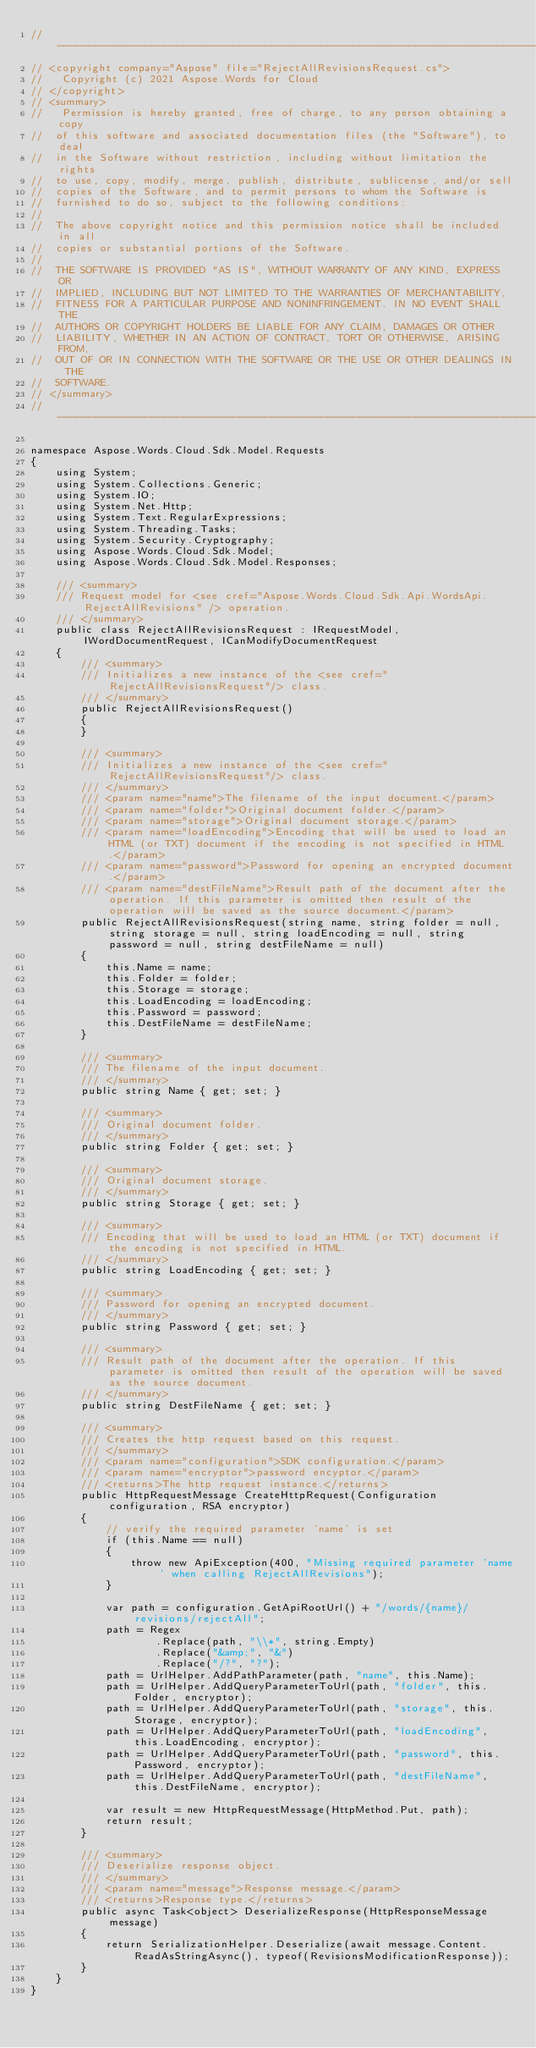Convert code to text. <code><loc_0><loc_0><loc_500><loc_500><_C#_>// --------------------------------------------------------------------------------------------------------------------
// <copyright company="Aspose" file="RejectAllRevisionsRequest.cs">
//   Copyright (c) 2021 Aspose.Words for Cloud
// </copyright>
// <summary>
//   Permission is hereby granted, free of charge, to any person obtaining a copy
//  of this software and associated documentation files (the "Software"), to deal
//  in the Software without restriction, including without limitation the rights
//  to use, copy, modify, merge, publish, distribute, sublicense, and/or sell
//  copies of the Software, and to permit persons to whom the Software is
//  furnished to do so, subject to the following conditions:
// 
//  The above copyright notice and this permission notice shall be included in all
//  copies or substantial portions of the Software.
// 
//  THE SOFTWARE IS PROVIDED "AS IS", WITHOUT WARRANTY OF ANY KIND, EXPRESS OR
//  IMPLIED, INCLUDING BUT NOT LIMITED TO THE WARRANTIES OF MERCHANTABILITY,
//  FITNESS FOR A PARTICULAR PURPOSE AND NONINFRINGEMENT. IN NO EVENT SHALL THE
//  AUTHORS OR COPYRIGHT HOLDERS BE LIABLE FOR ANY CLAIM, DAMAGES OR OTHER
//  LIABILITY, WHETHER IN AN ACTION OF CONTRACT, TORT OR OTHERWISE, ARISING FROM,
//  OUT OF OR IN CONNECTION WITH THE SOFTWARE OR THE USE OR OTHER DEALINGS IN THE
//  SOFTWARE.
// </summary>
// --------------------------------------------------------------------------------------------------------------------

namespace Aspose.Words.Cloud.Sdk.Model.Requests
{
    using System;
    using System.Collections.Generic;
    using System.IO;
    using System.Net.Http;
    using System.Text.RegularExpressions;
    using System.Threading.Tasks;
    using System.Security.Cryptography;
    using Aspose.Words.Cloud.Sdk.Model;
    using Aspose.Words.Cloud.Sdk.Model.Responses;

    /// <summary>
    /// Request model for <see cref="Aspose.Words.Cloud.Sdk.Api.WordsApi.RejectAllRevisions" /> operation.
    /// </summary>
    public class RejectAllRevisionsRequest : IRequestModel, IWordDocumentRequest, ICanModifyDocumentRequest
    {
        /// <summary>
        /// Initializes a new instance of the <see cref="RejectAllRevisionsRequest"/> class.
        /// </summary>
        public RejectAllRevisionsRequest()
        {
        }

        /// <summary>
        /// Initializes a new instance of the <see cref="RejectAllRevisionsRequest"/> class.
        /// </summary>
        /// <param name="name">The filename of the input document.</param>
        /// <param name="folder">Original document folder.</param>
        /// <param name="storage">Original document storage.</param>
        /// <param name="loadEncoding">Encoding that will be used to load an HTML (or TXT) document if the encoding is not specified in HTML.</param>
        /// <param name="password">Password for opening an encrypted document.</param>
        /// <param name="destFileName">Result path of the document after the operation. If this parameter is omitted then result of the operation will be saved as the source document.</param>
        public RejectAllRevisionsRequest(string name, string folder = null, string storage = null, string loadEncoding = null, string password = null, string destFileName = null)
        {
            this.Name = name;
            this.Folder = folder;
            this.Storage = storage;
            this.LoadEncoding = loadEncoding;
            this.Password = password;
            this.DestFileName = destFileName;
        }

        /// <summary>
        /// The filename of the input document.
        /// </summary>
        public string Name { get; set; }

        /// <summary>
        /// Original document folder.
        /// </summary>
        public string Folder { get; set; }

        /// <summary>
        /// Original document storage.
        /// </summary>
        public string Storage { get; set; }

        /// <summary>
        /// Encoding that will be used to load an HTML (or TXT) document if the encoding is not specified in HTML.
        /// </summary>
        public string LoadEncoding { get; set; }

        /// <summary>
        /// Password for opening an encrypted document.
        /// </summary>
        public string Password { get; set; }

        /// <summary>
        /// Result path of the document after the operation. If this parameter is omitted then result of the operation will be saved as the source document.
        /// </summary>
        public string DestFileName { get; set; }

        /// <summary>
        /// Creates the http request based on this request.
        /// </summary>
        /// <param name="configuration">SDK configuration.</param>
        /// <param name="encryptor">password encyptor.</param>
        /// <returns>The http request instance.</returns>
        public HttpRequestMessage CreateHttpRequest(Configuration configuration, RSA encryptor)
        {
            // verify the required parameter 'name' is set
            if (this.Name == null)
            {
                throw new ApiException(400, "Missing required parameter 'name' when calling RejectAllRevisions");
            }

            var path = configuration.GetApiRootUrl() + "/words/{name}/revisions/rejectAll";
            path = Regex
                    .Replace(path, "\\*", string.Empty)
                    .Replace("&amp;", "&")
                    .Replace("/?", "?");
            path = UrlHelper.AddPathParameter(path, "name", this.Name);
            path = UrlHelper.AddQueryParameterToUrl(path, "folder", this.Folder, encryptor);
            path = UrlHelper.AddQueryParameterToUrl(path, "storage", this.Storage, encryptor);
            path = UrlHelper.AddQueryParameterToUrl(path, "loadEncoding", this.LoadEncoding, encryptor);
            path = UrlHelper.AddQueryParameterToUrl(path, "password", this.Password, encryptor);
            path = UrlHelper.AddQueryParameterToUrl(path, "destFileName", this.DestFileName, encryptor);

            var result = new HttpRequestMessage(HttpMethod.Put, path);
            return result;
        }

        /// <summary>
        /// Deserialize response object.
        /// </summary>
        /// <param name="message">Response message.</param>
        /// <returns>Response type.</returns>
        public async Task<object> DeserializeResponse(HttpResponseMessage message)
        {
            return SerializationHelper.Deserialize(await message.Content.ReadAsStringAsync(), typeof(RevisionsModificationResponse));
        }
    }
}
</code> 